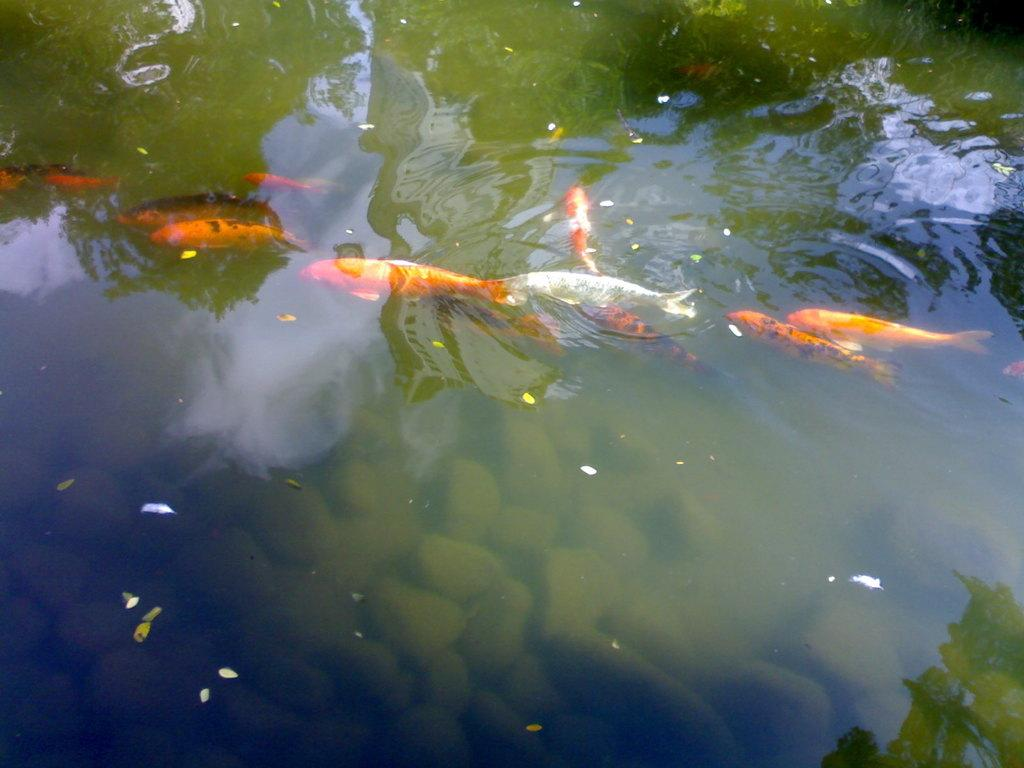What type of animals can be seen in the image? There are fish in the image. What other objects are present in the image? There are stones in the image. Where are the fish and stones located? The fish and stones are in the water. What type of cushion can be seen in the image? There is no cushion present in the image. What type of drink is being served in the image? There is no drink present in the image. 